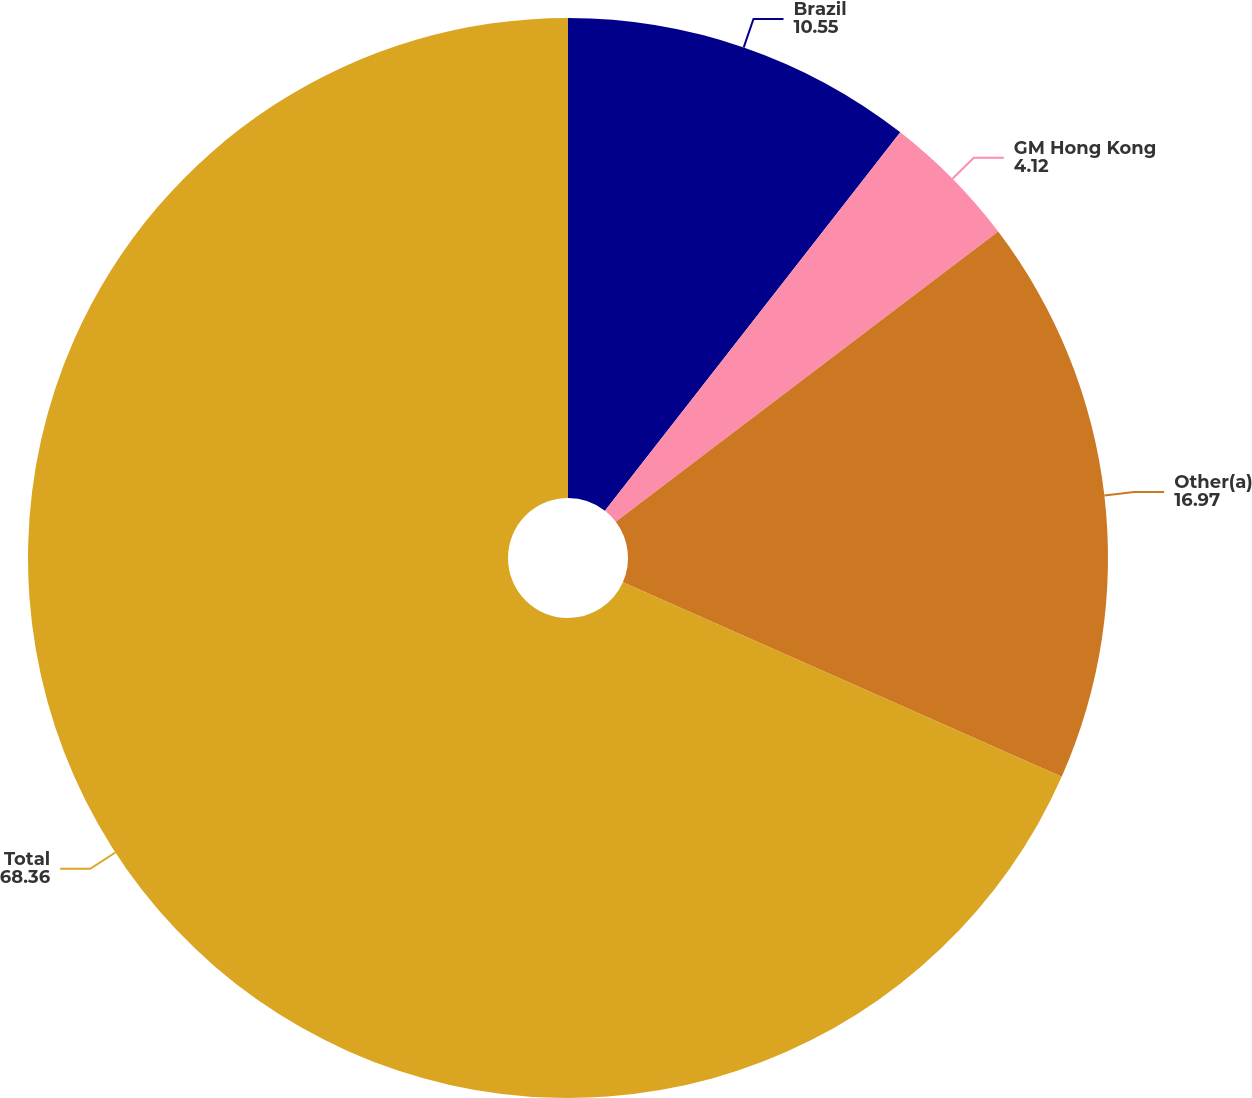Convert chart. <chart><loc_0><loc_0><loc_500><loc_500><pie_chart><fcel>Brazil<fcel>GM Hong Kong<fcel>Other(a)<fcel>Total<nl><fcel>10.55%<fcel>4.12%<fcel>16.97%<fcel>68.36%<nl></chart> 